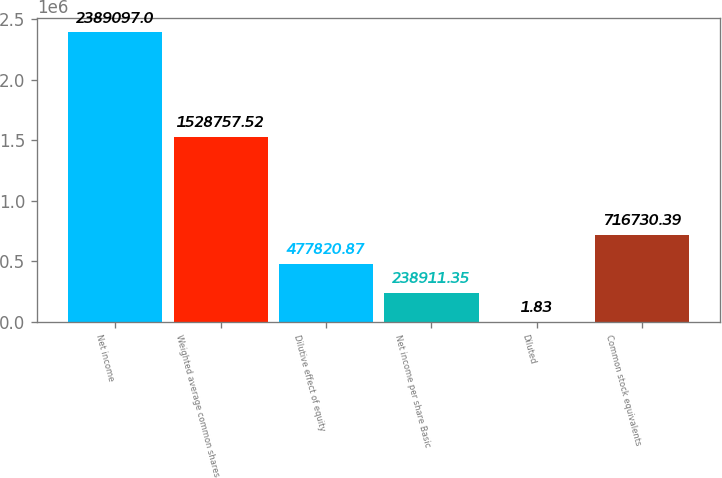Convert chart. <chart><loc_0><loc_0><loc_500><loc_500><bar_chart><fcel>Net income<fcel>Weighted average common shares<fcel>Dilutive effect of equity<fcel>Net income per share Basic<fcel>Diluted<fcel>Common stock equivalents<nl><fcel>2.3891e+06<fcel>1.52876e+06<fcel>477821<fcel>238911<fcel>1.83<fcel>716730<nl></chart> 